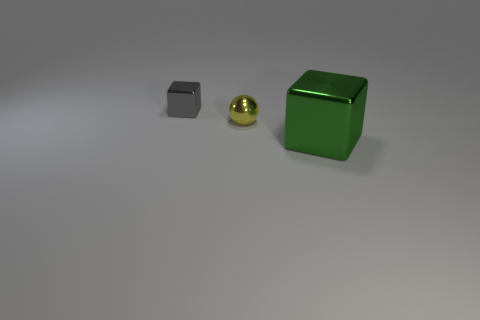Add 2 blue metallic cylinders. How many objects exist? 5 Subtract all spheres. How many objects are left? 2 Add 1 tiny yellow metal things. How many tiny yellow metal things are left? 2 Add 1 big green cylinders. How many big green cylinders exist? 1 Subtract 1 gray cubes. How many objects are left? 2 Subtract all large green spheres. Subtract all small objects. How many objects are left? 1 